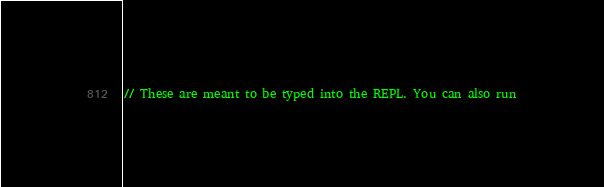Convert code to text. <code><loc_0><loc_0><loc_500><loc_500><_Scala_>// These are meant to be typed into the REPL. You can also run</code> 